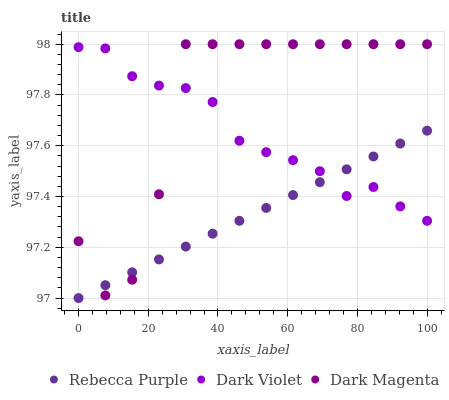Does Rebecca Purple have the minimum area under the curve?
Answer yes or no. Yes. Does Dark Magenta have the maximum area under the curve?
Answer yes or no. Yes. Does Dark Violet have the minimum area under the curve?
Answer yes or no. No. Does Dark Violet have the maximum area under the curve?
Answer yes or no. No. Is Rebecca Purple the smoothest?
Answer yes or no. Yes. Is Dark Magenta the roughest?
Answer yes or no. Yes. Is Dark Violet the smoothest?
Answer yes or no. No. Is Dark Violet the roughest?
Answer yes or no. No. Does Rebecca Purple have the lowest value?
Answer yes or no. Yes. Does Dark Magenta have the lowest value?
Answer yes or no. No. Does Dark Magenta have the highest value?
Answer yes or no. Yes. Does Dark Violet have the highest value?
Answer yes or no. No. Does Dark Magenta intersect Dark Violet?
Answer yes or no. Yes. Is Dark Magenta less than Dark Violet?
Answer yes or no. No. Is Dark Magenta greater than Dark Violet?
Answer yes or no. No. 